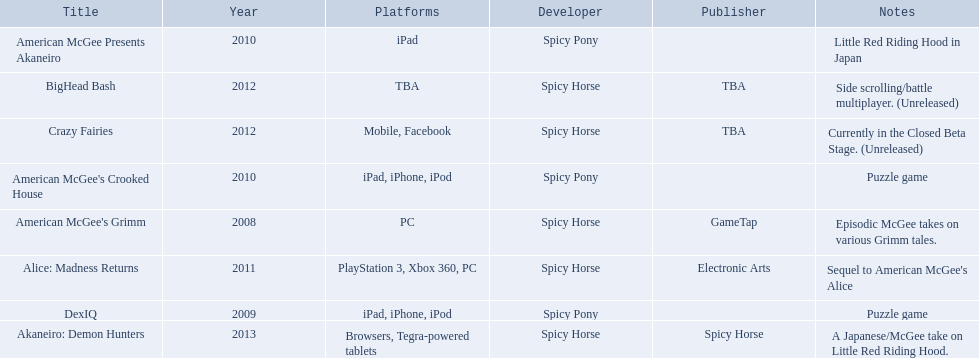What are all the titles of games published? American McGee's Grimm, DexIQ, American McGee Presents Akaneiro, American McGee's Crooked House, Alice: Madness Returns, BigHead Bash, Crazy Fairies, Akaneiro: Demon Hunters. What are all the names of the publishers? GameTap, , , , Electronic Arts, TBA, TBA, Spicy Horse. What is the published game title that corresponds to electronic arts? Alice: Madness Returns. 